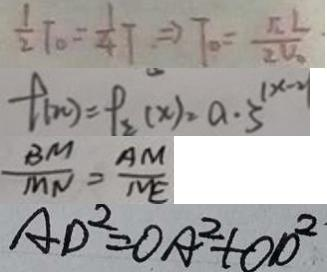<formula> <loc_0><loc_0><loc_500><loc_500>\frac { 1 } { 2 } T _ { o } = \frac { 1 } { 4 } T \Rightarrow T _ { o } = \frac { \sqrt { 2 } L } { 2 V _ { o } } 
 f ( n ) = f _ { 2 } ( x ) = a \cdot 3 ^ { ( x - 2 ) } 
 \frac { B M } { M N } = \frac { A M } { N E } 
 A D ^ { 2 } = O A ^ { 2 } + O D ^ { 2 }</formula> 